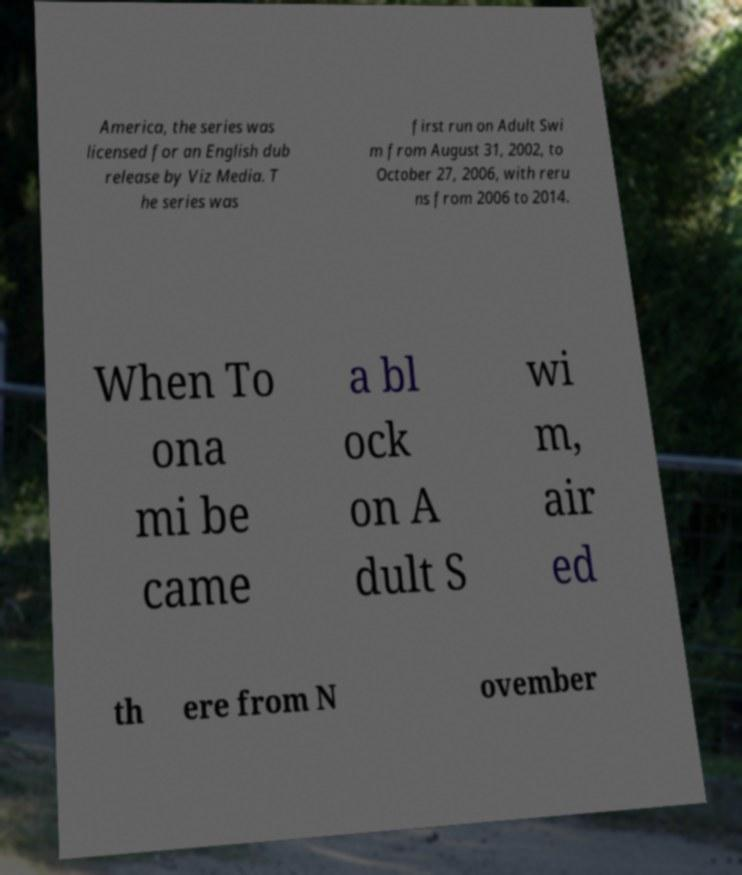Please read and relay the text visible in this image. What does it say? America, the series was licensed for an English dub release by Viz Media. T he series was first run on Adult Swi m from August 31, 2002, to October 27, 2006, with reru ns from 2006 to 2014. When To ona mi be came a bl ock on A dult S wi m, air ed th ere from N ovember 